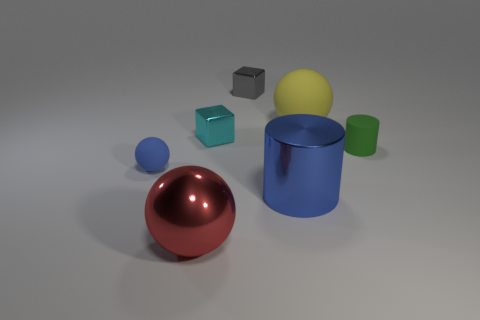Can you estimate the sizes of the objects in relation to each other? It appears that the red sphere is the largest object in diameter, followed by the blue cylinder. The green cylinder and the yellow sphere are smaller, and the two cubes are the smallest objects, with the gray one being slightly larger than the turquoise. 